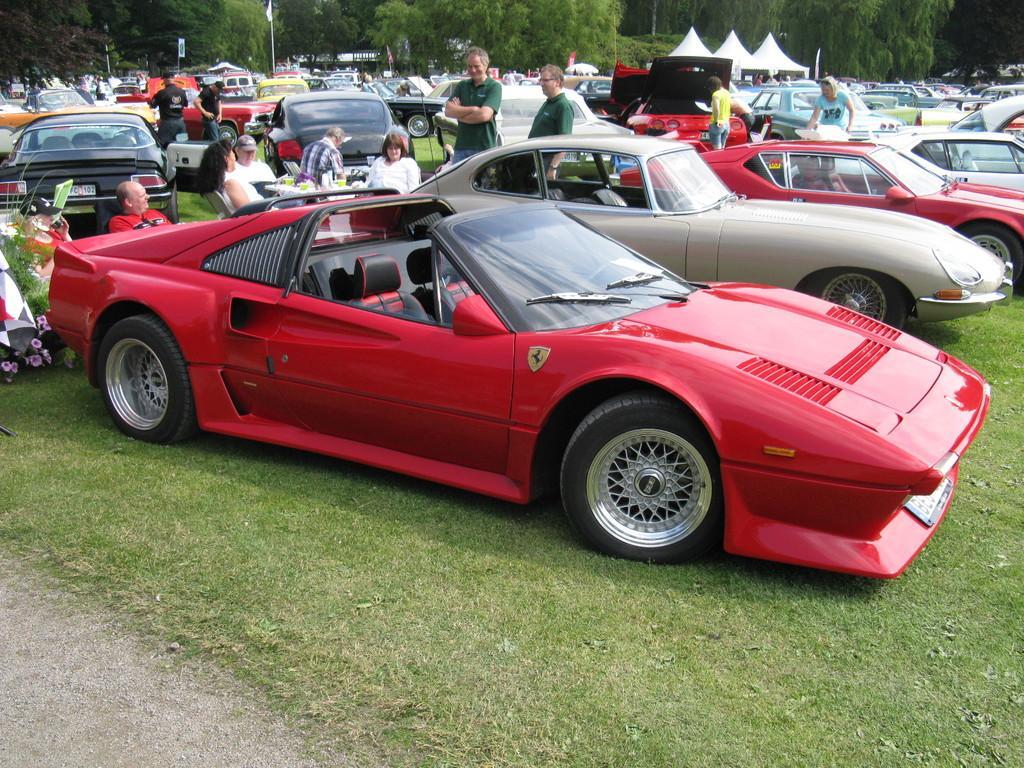Describe this image in one or two sentences. In this image there are cars on a ground there are people sitting on chairs and few are standing, in the background there are tents and trees. 